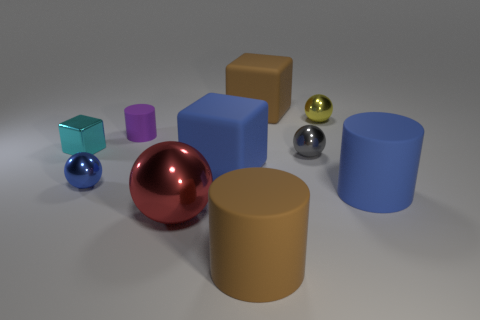Subtract all cyan spheres. Subtract all blue blocks. How many spheres are left? 4 Subtract all cylinders. How many objects are left? 7 Subtract 0 green cylinders. How many objects are left? 10 Subtract all large matte cylinders. Subtract all big purple cubes. How many objects are left? 8 Add 8 big balls. How many big balls are left? 9 Add 2 blue objects. How many blue objects exist? 5 